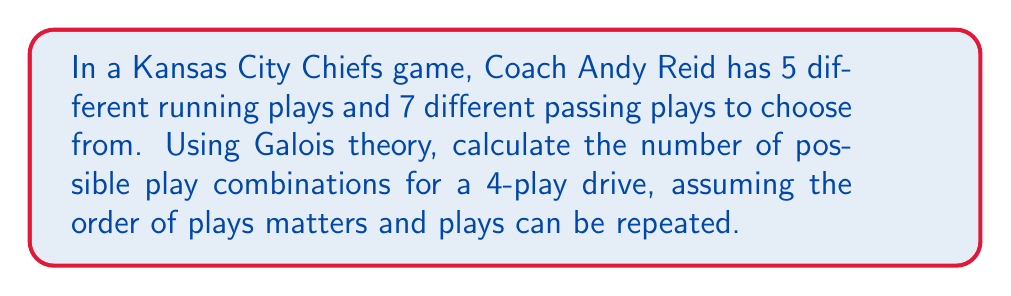Teach me how to tackle this problem. Let's approach this step-by-step using concepts from Galois theory:

1) First, we need to recognize that this problem involves a finite field extension. The total number of play options (12) forms our base field.

2) We're looking at sequences of 4 plays, which can be thought of as a degree 4 extension of our base field.

3) In Galois theory, the number of elements in a finite field extension is given by $q^n$, where $q$ is the number of elements in the base field and $n$ is the degree of the extension.

4) In this case:
   $q = 12$ (total number of play options)
   $n = 4$ (number of plays in the sequence)

5) Therefore, the number of possible play combinations is:

   $$12^4 = 20,736$$

6) This result can be interpreted as follows:
   - For each of the 4 plays, we have 12 choices
   - These choices are independent (order matters and repetition is allowed)
   - So we multiply the number of choices for each play: 12 * 12 * 12 * 12

7) In terms of Galois theory, this represents all possible elements in the field extension, each corresponding to a unique 4-play sequence.
Answer: 20,736 